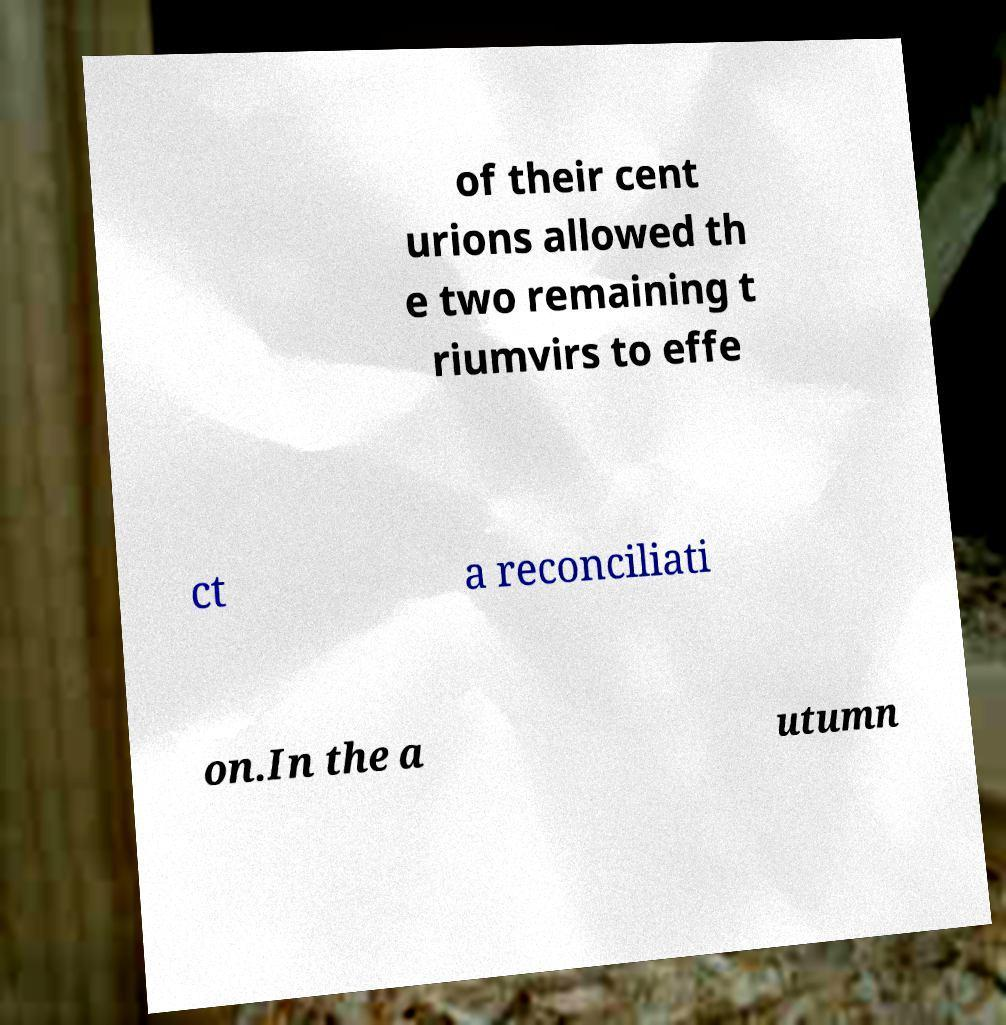For documentation purposes, I need the text within this image transcribed. Could you provide that? of their cent urions allowed th e two remaining t riumvirs to effe ct a reconciliati on.In the a utumn 